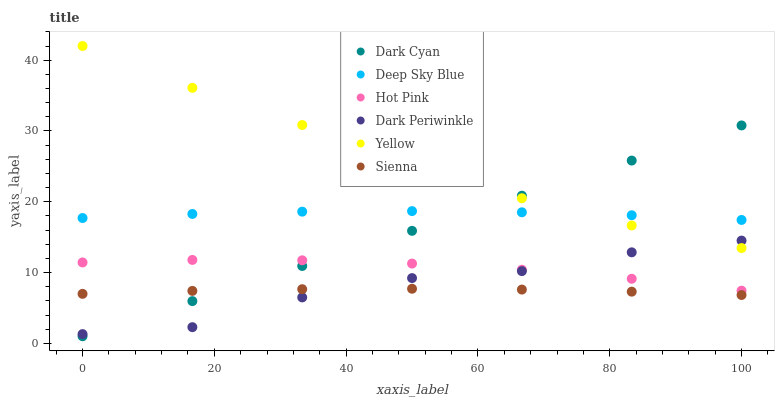Does Sienna have the minimum area under the curve?
Answer yes or no. Yes. Does Yellow have the maximum area under the curve?
Answer yes or no. Yes. Does Yellow have the minimum area under the curve?
Answer yes or no. No. Does Sienna have the maximum area under the curve?
Answer yes or no. No. Is Dark Cyan the smoothest?
Answer yes or no. Yes. Is Yellow the roughest?
Answer yes or no. Yes. Is Sienna the smoothest?
Answer yes or no. No. Is Sienna the roughest?
Answer yes or no. No. Does Dark Cyan have the lowest value?
Answer yes or no. Yes. Does Yellow have the lowest value?
Answer yes or no. No. Does Yellow have the highest value?
Answer yes or no. Yes. Does Sienna have the highest value?
Answer yes or no. No. Is Sienna less than Deep Sky Blue?
Answer yes or no. Yes. Is Deep Sky Blue greater than Dark Periwinkle?
Answer yes or no. Yes. Does Dark Periwinkle intersect Yellow?
Answer yes or no. Yes. Is Dark Periwinkle less than Yellow?
Answer yes or no. No. Is Dark Periwinkle greater than Yellow?
Answer yes or no. No. Does Sienna intersect Deep Sky Blue?
Answer yes or no. No. 